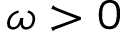Convert formula to latex. <formula><loc_0><loc_0><loc_500><loc_500>\omega > 0</formula> 